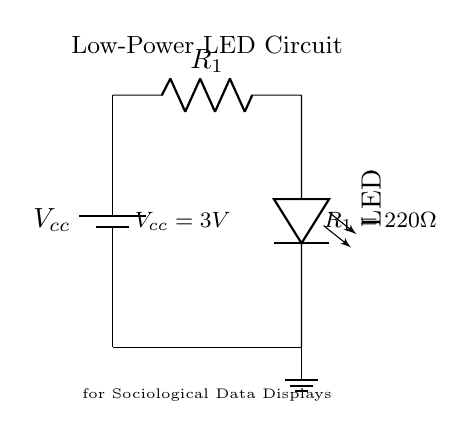What is the voltage of the power source? The voltage of the power source is indicated as Vcc in the circuit diagram, which has a value of 3V specified in the labels.
Answer: 3V What type of component is used for current limiting? The component used for current limiting is labeled as R1, which is a resistor in the diagram. This limits the current that flows through the LED to prevent damage.
Answer: Resistor What is the resistance value of the current limiting resistor? The resistance value of the current limiting resistor R1 is indicated as 220 Ohms in the labels on the circuit.
Answer: 220 Ohm How many components are in the circuit? The circuit consists of three components: a battery, a resistor, and an LED. The labels and the connections between these components indicate their presence.
Answer: Three What happens if the resistor value is increased? If the resistor value is increased, the current flowing through the LED will decrease, resulting in a dimmer light output or potentially turning off the LED if the resistance is too high. This reasoning comes from Ohm's law, which states that current is inversely proportional to resistance for a constant voltage.
Answer: LED dims What is the purpose of using a low-power LED in this circuit? The purpose of using a low-power LED is to provide efficient illumination for the sociological data displays while consuming minimal electrical power. This is crucial for extending battery life and making the circuit suitable for low-power applications.
Answer: Efficient illumination What is the orientation of the LED in the circuit? The orientation of the LED is vertical in the diagram, which impacts its light emission direction. The rotational label implies it is mounted in a way to illuminate the area above it.
Answer: Vertical 